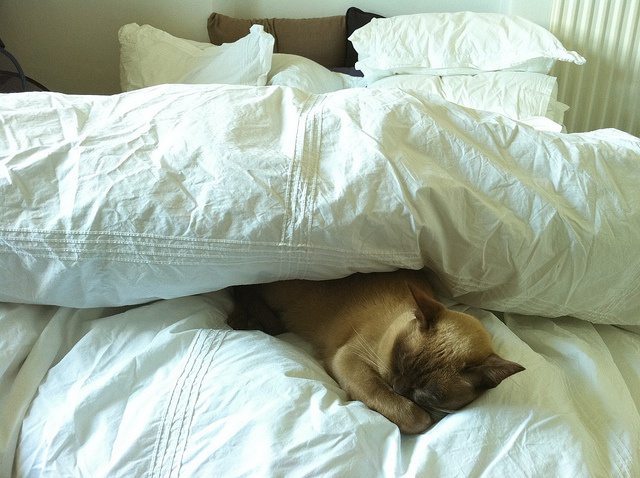Describe the objects in this image and their specific colors. I can see bed in white, darkgreen, darkgray, gray, and lightblue tones and cat in darkgreen, black, and olive tones in this image. 